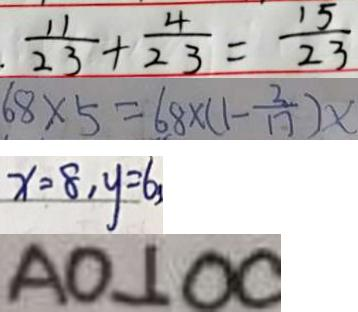<formula> <loc_0><loc_0><loc_500><loc_500>\frac { 1 1 } { 2 3 } + \frac { 4 } { 2 3 } = \frac { 1 5 } { 2 3 } 
 6 8 \times 5 = 6 8 \times ( 1 - \frac { 2 } { 1 7 } ) x 
 x = 8 , y = 6 
 A O \bot 0 0</formula> 